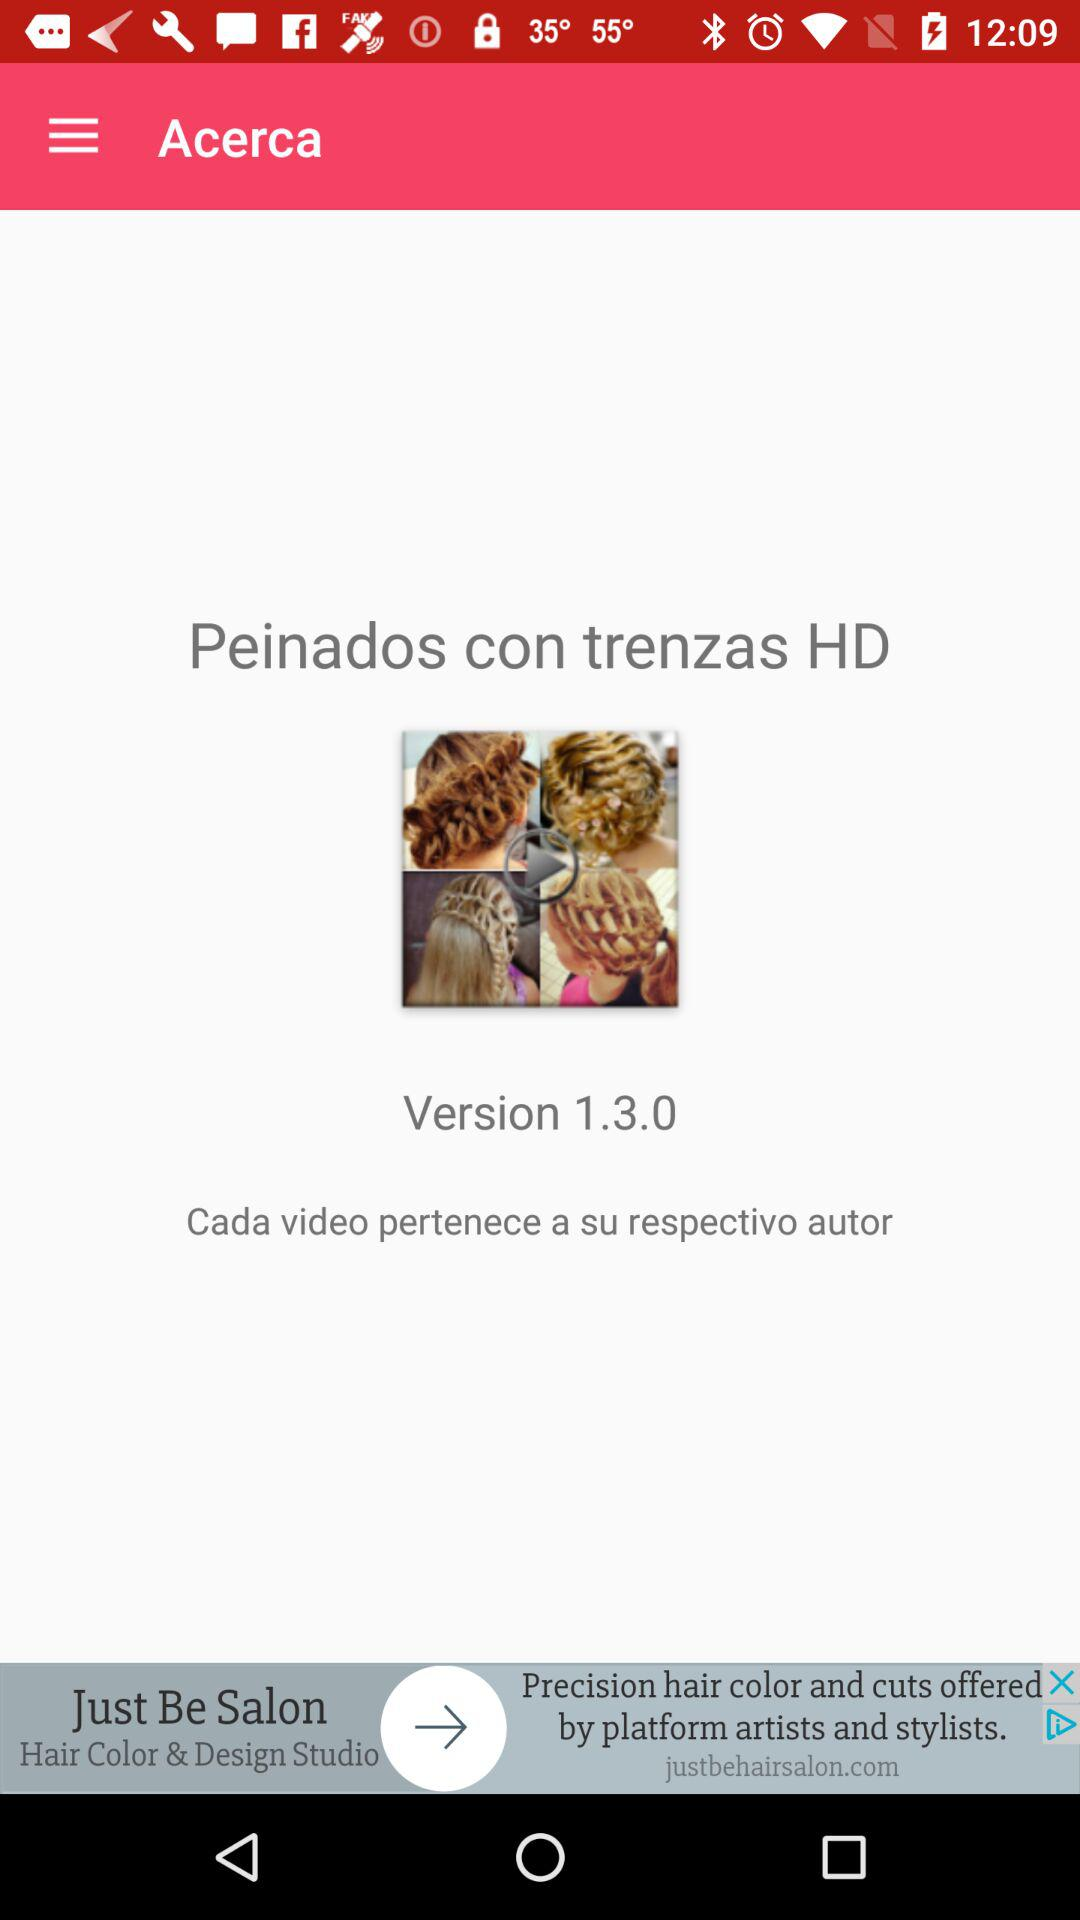What is the version? The version is 1.3.0. 